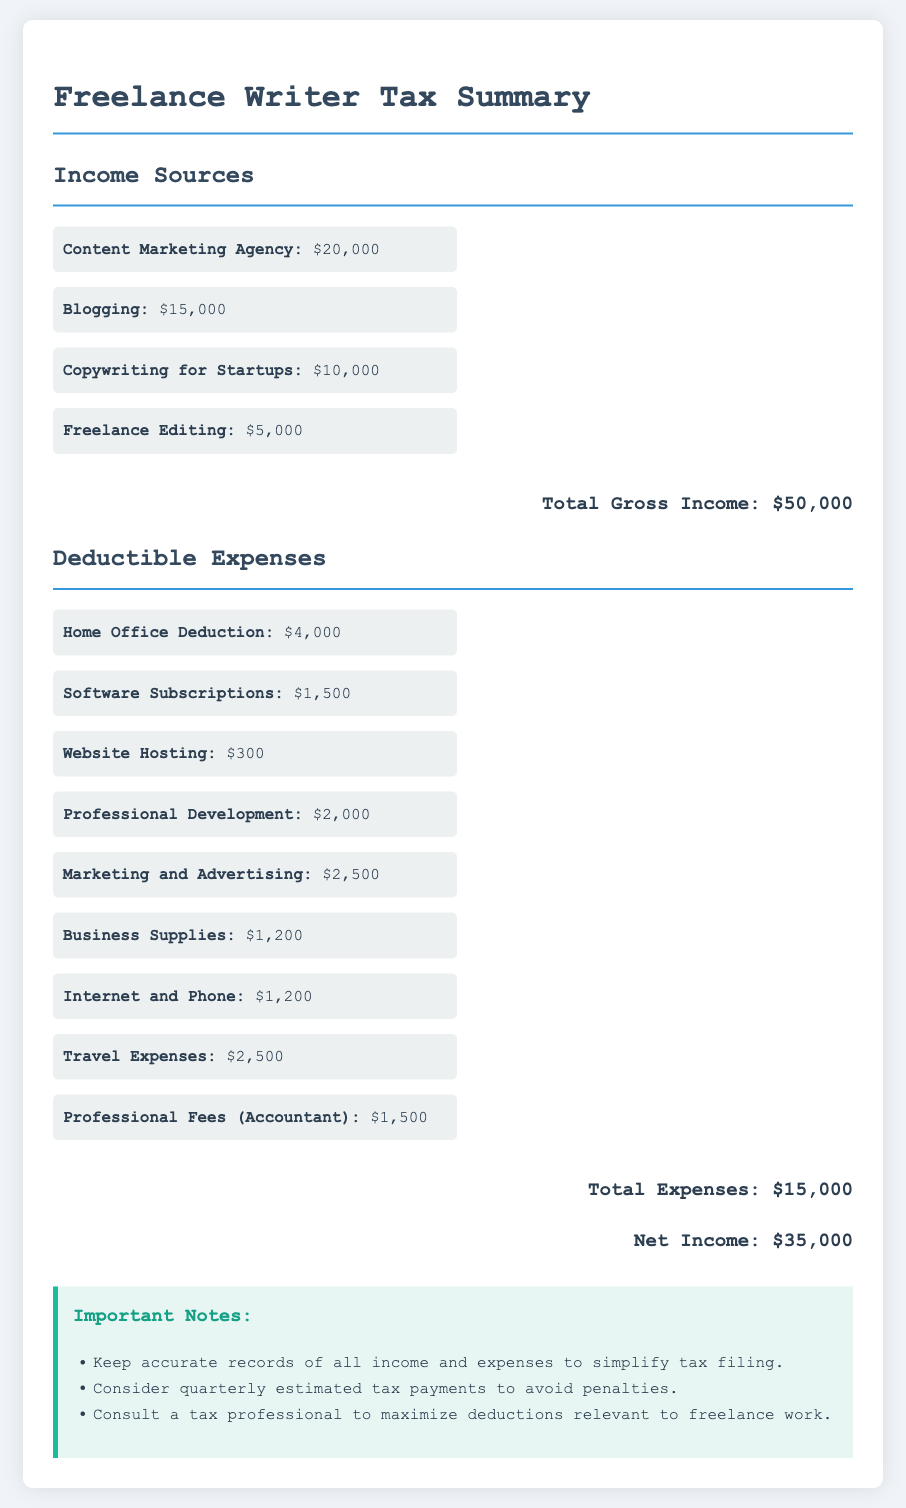What is the total gross income? The total gross income is the sum of all income sources listed in the document: $20,000 + $15,000 + $10,000 + $5,000 = $50,000.
Answer: $50,000 What is the amount for the Home Office Deduction? The Home Office Deduction listed in the document is a specific deductible expense.
Answer: $4,000 How much did the Freelance Editing contribute to income? The Freelance Editing income amount is specified in the income sources section of the document.
Answer: $5,000 What is the total amount of deductible expenses? The total deductible expenses is calculated by adding all the individual deductible expenses mentioned in the document: $4,000 + $1,500 + $300 + $2,000 + $2,500 + $1,200 + $1,200 + $2,500 + $1,500 = $15,000.
Answer: $15,000 What is the net income for the tax year? The net income is calculated by subtracting total expenses from total gross income as presented in the document.
Answer: $35,000 How much was spent on Travel Expenses? Travel Expenses are specifically mentioned as one of the deductible expenses in the document.
Answer: $2,500 What is one important note regarding records? The document includes important notes for the freelance writer about tax preparation, one of which emphasizes keeping accurate records.
Answer: Keep accurate records What percentage of total income comes from Blogging? The income from Blogging is one of the sources, and it needs to be calculated against the total gross income.
Answer: 30 percent What type of document is this? The document presents a summary related to tax preparation for a specific profession.
Answer: Financial report 